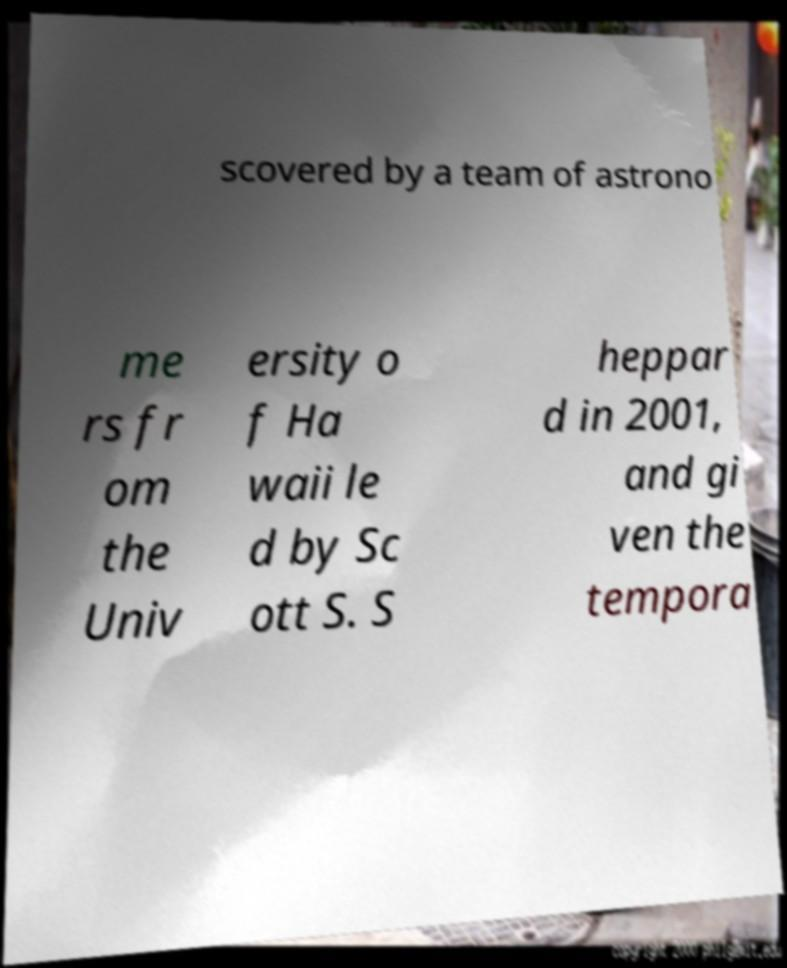Could you assist in decoding the text presented in this image and type it out clearly? scovered by a team of astrono me rs fr om the Univ ersity o f Ha waii le d by Sc ott S. S heppar d in 2001, and gi ven the tempora 